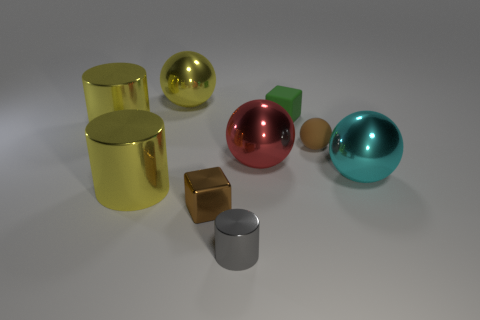Subtract all yellow balls. How many balls are left? 3 Subtract all large yellow spheres. How many spheres are left? 3 Add 1 green rubber objects. How many objects exist? 10 Subtract all green spheres. Subtract all yellow blocks. How many spheres are left? 4 Subtract all cubes. How many objects are left? 7 Add 5 tiny red spheres. How many tiny red spheres exist? 5 Subtract 0 brown cylinders. How many objects are left? 9 Subtract all small red cylinders. Subtract all gray metal cylinders. How many objects are left? 8 Add 1 big yellow shiny spheres. How many big yellow shiny spheres are left? 2 